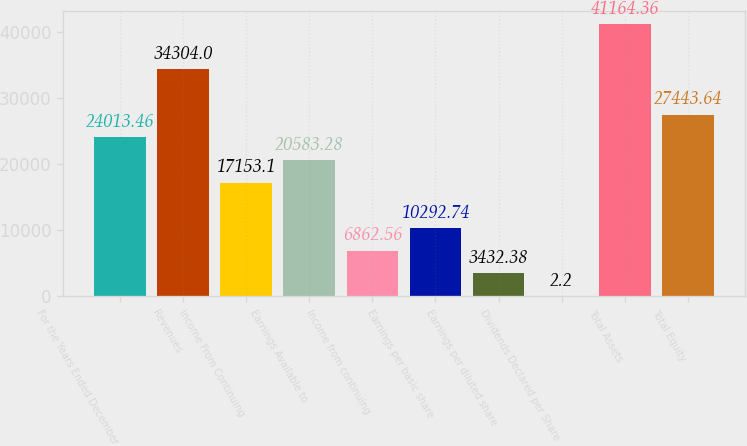Convert chart. <chart><loc_0><loc_0><loc_500><loc_500><bar_chart><fcel>For the Years Ended December<fcel>Revenues<fcel>Income From Continuing<fcel>Earnings Available to<fcel>Income from continuing<fcel>Earnings per basic share<fcel>Earnings per diluted share<fcel>Dividends Declared per Share<fcel>Total Assets<fcel>Total Equity<nl><fcel>24013.5<fcel>34304<fcel>17153.1<fcel>20583.3<fcel>6862.56<fcel>10292.7<fcel>3432.38<fcel>2.2<fcel>41164.4<fcel>27443.6<nl></chart> 